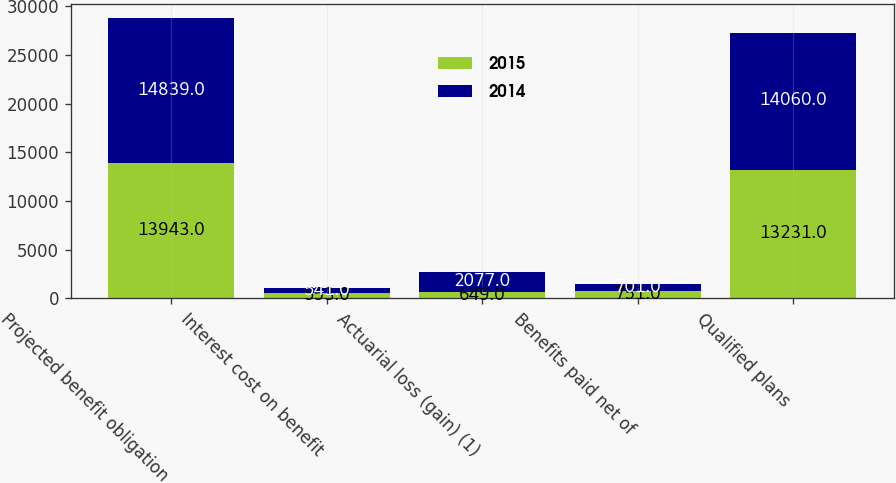Convert chart. <chart><loc_0><loc_0><loc_500><loc_500><stacked_bar_chart><ecel><fcel>Projected benefit obligation<fcel>Interest cost on benefit<fcel>Actuarial loss (gain) (1)<fcel>Benefits paid net of<fcel>Qualified plans<nl><fcel>2015<fcel>13943<fcel>553<fcel>649<fcel>751<fcel>13231<nl><fcel>2014<fcel>14839<fcel>541<fcel>2077<fcel>701<fcel>14060<nl></chart> 